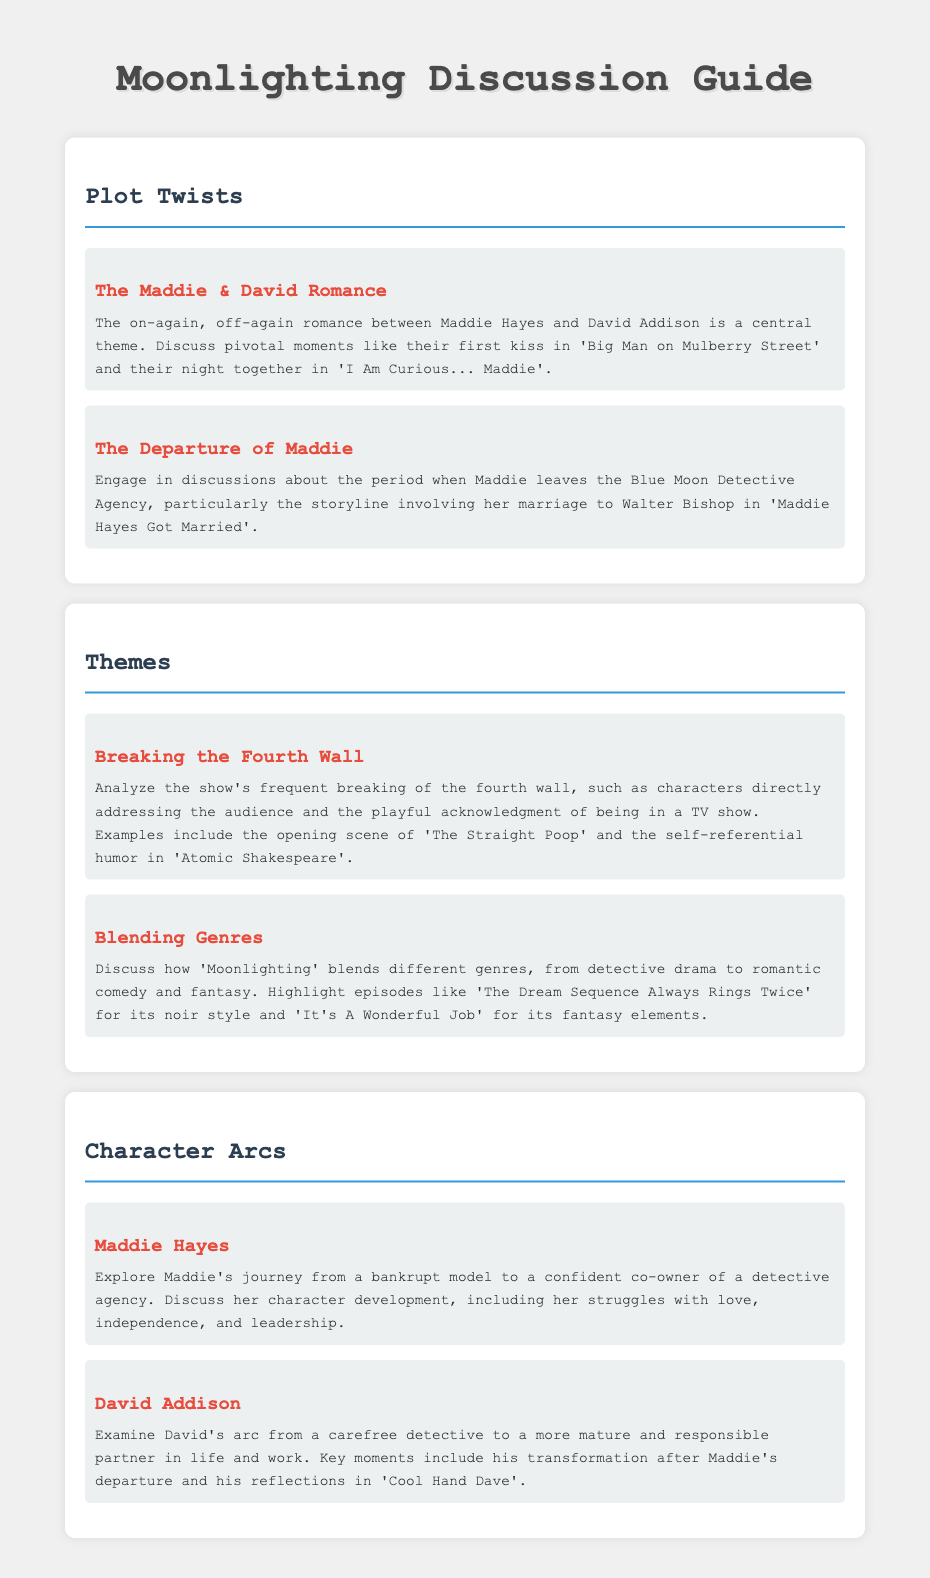what is a central theme involving Maddie and David? The document mentions that the central theme is the on-again, off-again romance between Maddie Hayes and David Addison, highlighted by their first kiss in 'Big Man on Mulberry Street'.
Answer: Maddie & David Romance what significant event happens in 'Maddie Hayes Got Married'? The document states that this episode involves Maddie's departure from the Blue Moon Detective Agency and her marriage to Walter Bishop.
Answer: Maddie's marriage to Walter Bishop which episode features a major scene where the fourth wall is broken? The document lists the opening scene of 'The Straight Poop' as a key example of breaking the fourth wall.
Answer: The Straight Poop what genre is blended with detective drama in 'Moonlighting'? The document discusses the blending of genres, mentioning romantic comedy alongside detective drama.
Answer: Romantic comedy how does Maddie's character develop throughout the series? The document states that she evolves from a bankrupt model to a confident co-owner of a detective agency, facing struggles with love and leadership.
Answer: Confident co-owner of a detective agency what happens to David Addison after Maddie's departure? The document notes that David transforms into a more mature and responsible partner in life and work.
Answer: More mature and responsible which episode is highlighted for its noir style? The document mentions 'The Dream Sequence Always Rings Twice' as an episode with noir style.
Answer: The Dream Sequence Always Rings Twice what is a key theme in the show's humor style? The document discusses the self-referential humor as a significant theme, evident in episodes like 'Atomic Shakespeare'.
Answer: Self-referential humor 